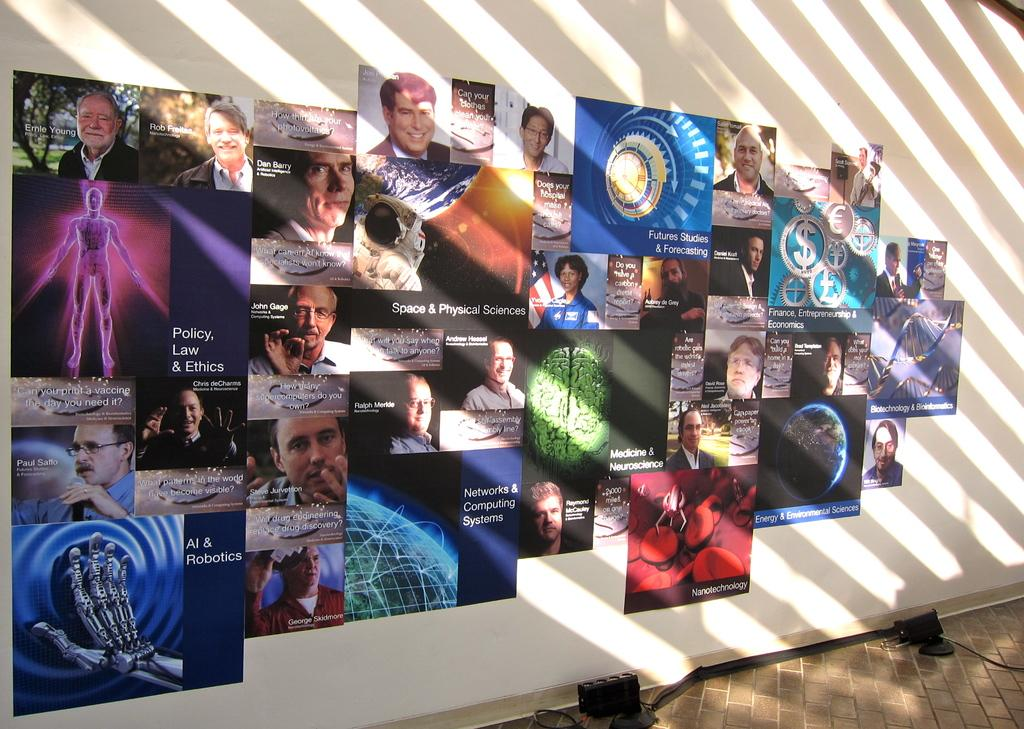What is displayed on the white color wall in the image? There are photos of persons on a white color wall. Are there any other items attached to the wall besides the photos? Yes, there are other objects attached to the white color wall. What can be seen on the floor in the image? There are objects on the floor. What type of tomatoes are being used as a representative for the invention in the image? There are no tomatoes or inventions present in the image. 